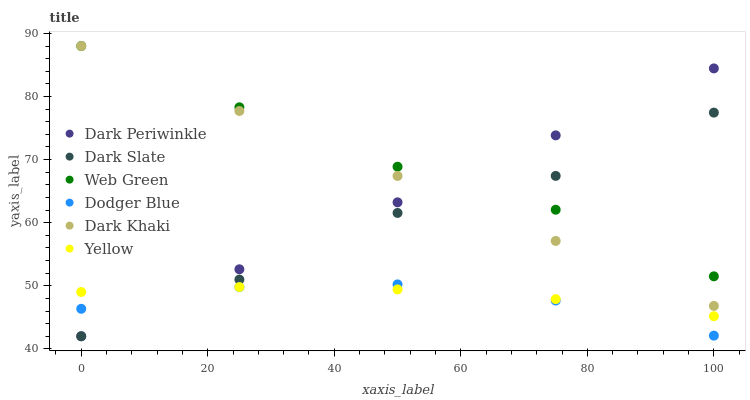Does Dodger Blue have the minimum area under the curve?
Answer yes or no. Yes. Does Web Green have the maximum area under the curve?
Answer yes or no. Yes. Does Dark Khaki have the minimum area under the curve?
Answer yes or no. No. Does Dark Khaki have the maximum area under the curve?
Answer yes or no. No. Is Dark Periwinkle the smoothest?
Answer yes or no. Yes. Is Dark Slate the roughest?
Answer yes or no. Yes. Is Dark Khaki the smoothest?
Answer yes or no. No. Is Dark Khaki the roughest?
Answer yes or no. No. Does Dark Slate have the lowest value?
Answer yes or no. Yes. Does Dark Khaki have the lowest value?
Answer yes or no. No. Does Web Green have the highest value?
Answer yes or no. Yes. Does Dark Slate have the highest value?
Answer yes or no. No. Is Dodger Blue less than Web Green?
Answer yes or no. Yes. Is Web Green greater than Yellow?
Answer yes or no. Yes. Does Dark Slate intersect Dodger Blue?
Answer yes or no. Yes. Is Dark Slate less than Dodger Blue?
Answer yes or no. No. Is Dark Slate greater than Dodger Blue?
Answer yes or no. No. Does Dodger Blue intersect Web Green?
Answer yes or no. No. 